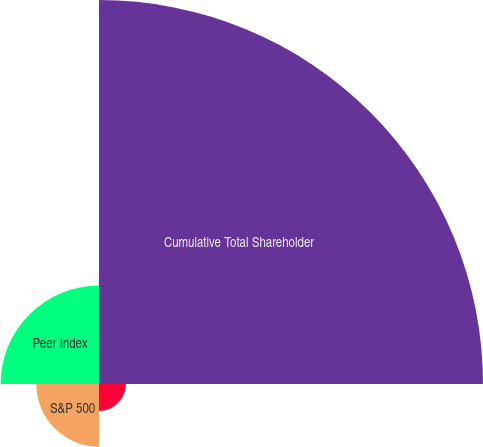Convert chart to OTSL. <chart><loc_0><loc_0><loc_500><loc_500><pie_chart><fcel>Cumulative Total Shareholder<fcel>Rollins Inc<fcel>S&P 500<fcel>Peer Index<nl><fcel>67.13%<fcel>4.71%<fcel>10.96%<fcel>17.2%<nl></chart> 